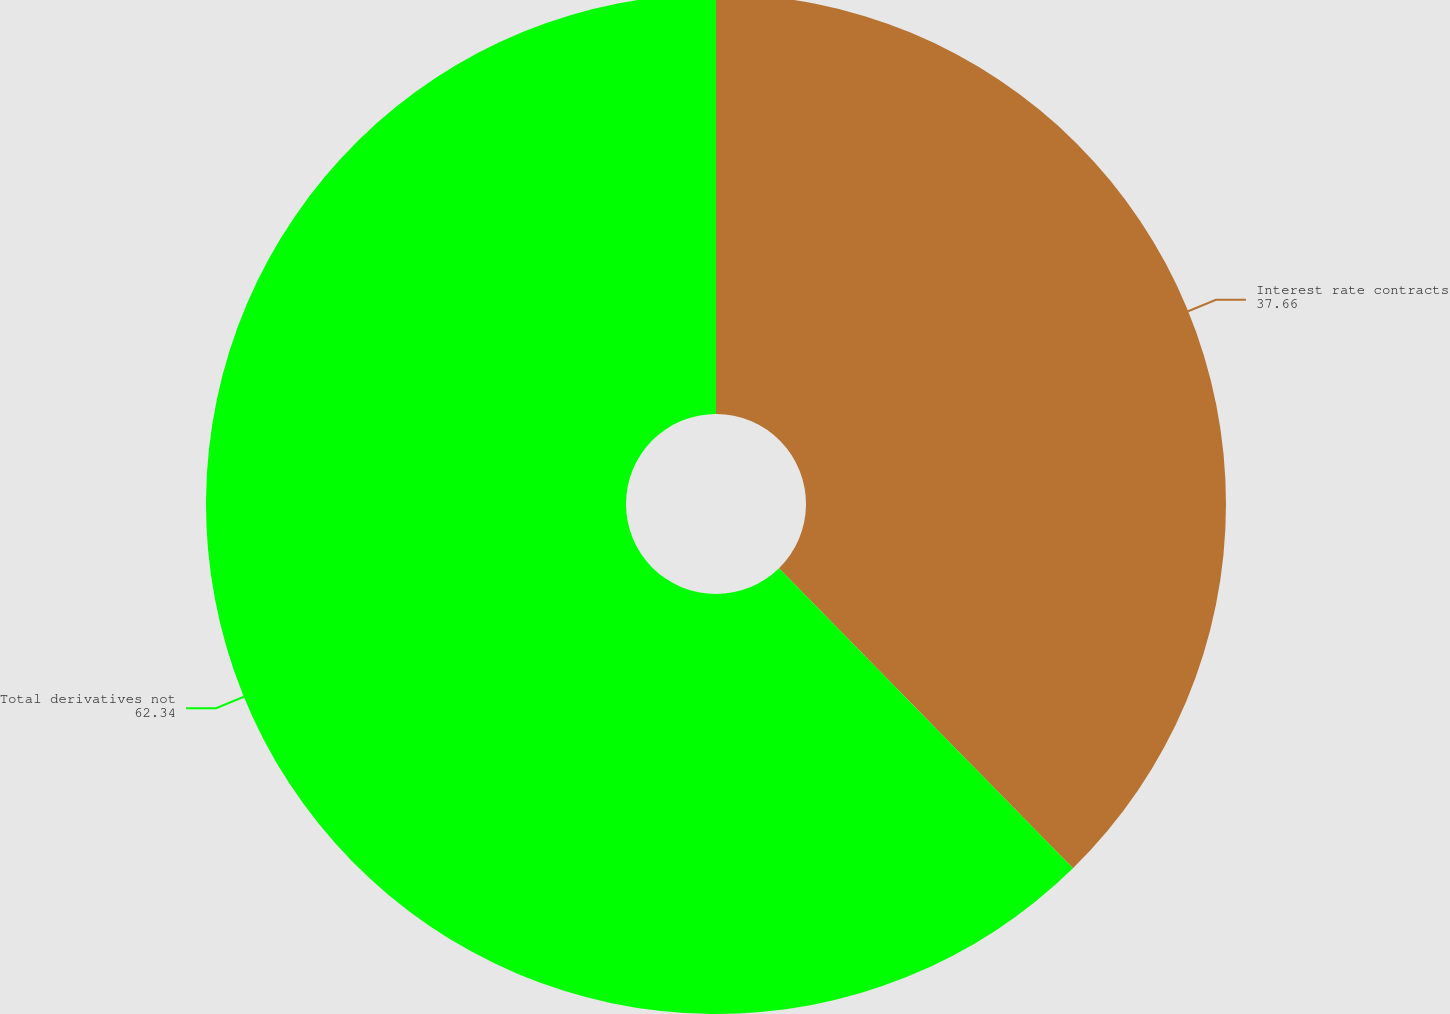Convert chart. <chart><loc_0><loc_0><loc_500><loc_500><pie_chart><fcel>Interest rate contracts<fcel>Total derivatives not<nl><fcel>37.66%<fcel>62.34%<nl></chart> 